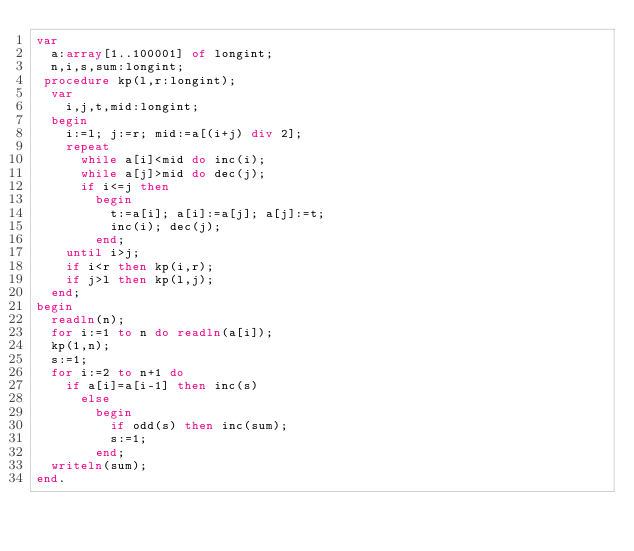<code> <loc_0><loc_0><loc_500><loc_500><_Pascal_>var
  a:array[1..100001] of longint;
  n,i,s,sum:longint;
 procedure kp(l,r:longint);
  var
    i,j,t,mid:longint;
  begin
    i:=l; j:=r; mid:=a[(i+j) div 2];
    repeat
      while a[i]<mid do inc(i);
      while a[j]>mid do dec(j);
      if i<=j then
        begin
          t:=a[i]; a[i]:=a[j]; a[j]:=t;
          inc(i); dec(j);
        end;
    until i>j;
    if i<r then kp(i,r);
    if j>l then kp(l,j);
  end;
begin
  readln(n);
  for i:=1 to n do readln(a[i]);
  kp(1,n);
  s:=1;
  for i:=2 to n+1 do
    if a[i]=a[i-1] then inc(s)
      else
        begin
          if odd(s) then inc(sum);
          s:=1;
        end;
  writeln(sum);
end.</code> 